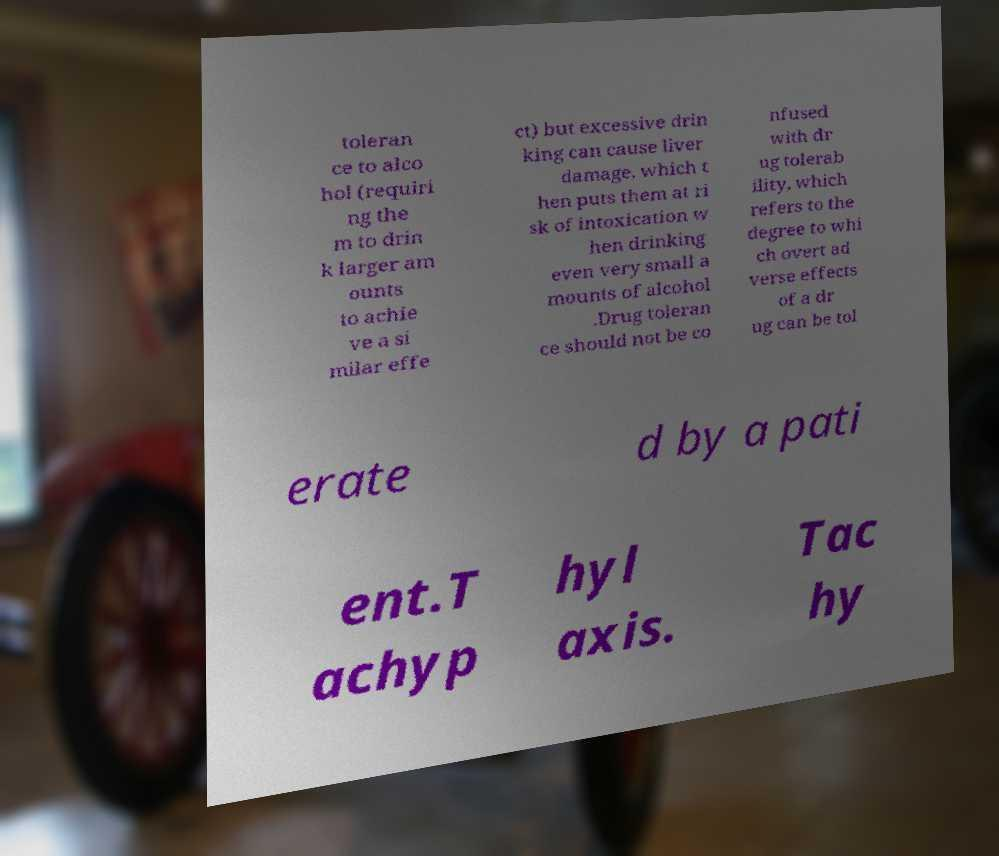Please identify and transcribe the text found in this image. toleran ce to alco hol (requiri ng the m to drin k larger am ounts to achie ve a si milar effe ct) but excessive drin king can cause liver damage, which t hen puts them at ri sk of intoxication w hen drinking even very small a mounts of alcohol .Drug toleran ce should not be co nfused with dr ug tolerab ility, which refers to the degree to whi ch overt ad verse effects of a dr ug can be tol erate d by a pati ent.T achyp hyl axis. Tac hy 